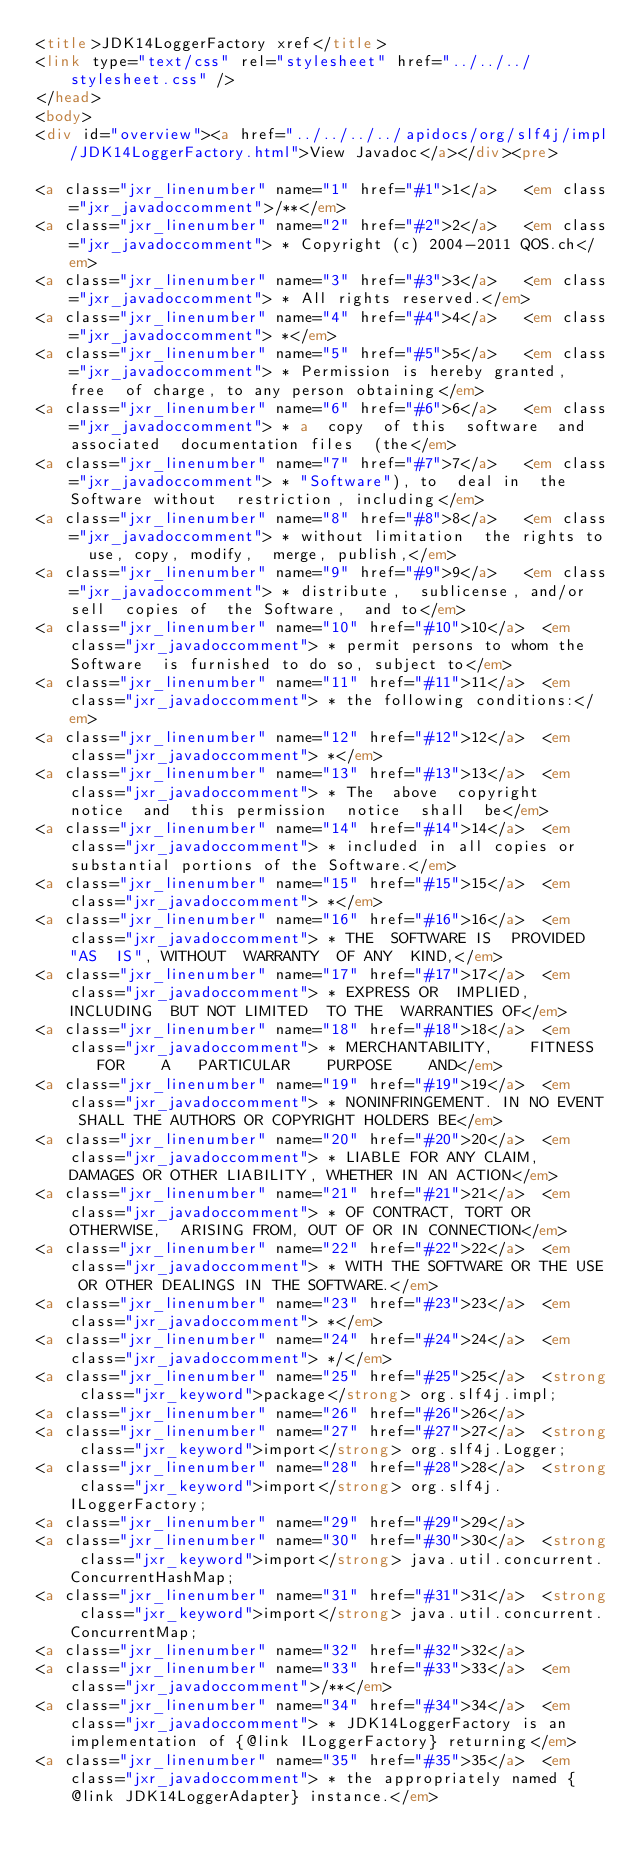Convert code to text. <code><loc_0><loc_0><loc_500><loc_500><_HTML_><title>JDK14LoggerFactory xref</title>
<link type="text/css" rel="stylesheet" href="../../../stylesheet.css" />
</head>
<body>
<div id="overview"><a href="../../../../apidocs/org/slf4j/impl/JDK14LoggerFactory.html">View Javadoc</a></div><pre>

<a class="jxr_linenumber" name="1" href="#1">1</a>   <em class="jxr_javadoccomment">/**</em>
<a class="jxr_linenumber" name="2" href="#2">2</a>   <em class="jxr_javadoccomment"> * Copyright (c) 2004-2011 QOS.ch</em>
<a class="jxr_linenumber" name="3" href="#3">3</a>   <em class="jxr_javadoccomment"> * All rights reserved.</em>
<a class="jxr_linenumber" name="4" href="#4">4</a>   <em class="jxr_javadoccomment"> *</em>
<a class="jxr_linenumber" name="5" href="#5">5</a>   <em class="jxr_javadoccomment"> * Permission is hereby granted, free  of charge, to any person obtaining</em>
<a class="jxr_linenumber" name="6" href="#6">6</a>   <em class="jxr_javadoccomment"> * a  copy  of this  software  and  associated  documentation files  (the</em>
<a class="jxr_linenumber" name="7" href="#7">7</a>   <em class="jxr_javadoccomment"> * "Software"), to  deal in  the Software without  restriction, including</em>
<a class="jxr_linenumber" name="8" href="#8">8</a>   <em class="jxr_javadoccomment"> * without limitation  the rights to  use, copy, modify,  merge, publish,</em>
<a class="jxr_linenumber" name="9" href="#9">9</a>   <em class="jxr_javadoccomment"> * distribute,  sublicense, and/or sell  copies of  the Software,  and to</em>
<a class="jxr_linenumber" name="10" href="#10">10</a>  <em class="jxr_javadoccomment"> * permit persons to whom the Software  is furnished to do so, subject to</em>
<a class="jxr_linenumber" name="11" href="#11">11</a>  <em class="jxr_javadoccomment"> * the following conditions:</em>
<a class="jxr_linenumber" name="12" href="#12">12</a>  <em class="jxr_javadoccomment"> *</em>
<a class="jxr_linenumber" name="13" href="#13">13</a>  <em class="jxr_javadoccomment"> * The  above  copyright  notice  and  this permission  notice  shall  be</em>
<a class="jxr_linenumber" name="14" href="#14">14</a>  <em class="jxr_javadoccomment"> * included in all copies or substantial portions of the Software.</em>
<a class="jxr_linenumber" name="15" href="#15">15</a>  <em class="jxr_javadoccomment"> *</em>
<a class="jxr_linenumber" name="16" href="#16">16</a>  <em class="jxr_javadoccomment"> * THE  SOFTWARE IS  PROVIDED  "AS  IS", WITHOUT  WARRANTY  OF ANY  KIND,</em>
<a class="jxr_linenumber" name="17" href="#17">17</a>  <em class="jxr_javadoccomment"> * EXPRESS OR  IMPLIED, INCLUDING  BUT NOT LIMITED  TO THE  WARRANTIES OF</em>
<a class="jxr_linenumber" name="18" href="#18">18</a>  <em class="jxr_javadoccomment"> * MERCHANTABILITY,    FITNESS    FOR    A   PARTICULAR    PURPOSE    AND</em>
<a class="jxr_linenumber" name="19" href="#19">19</a>  <em class="jxr_javadoccomment"> * NONINFRINGEMENT. IN NO EVENT SHALL THE AUTHORS OR COPYRIGHT HOLDERS BE</em>
<a class="jxr_linenumber" name="20" href="#20">20</a>  <em class="jxr_javadoccomment"> * LIABLE FOR ANY CLAIM, DAMAGES OR OTHER LIABILITY, WHETHER IN AN ACTION</em>
<a class="jxr_linenumber" name="21" href="#21">21</a>  <em class="jxr_javadoccomment"> * OF CONTRACT, TORT OR OTHERWISE,  ARISING FROM, OUT OF OR IN CONNECTION</em>
<a class="jxr_linenumber" name="22" href="#22">22</a>  <em class="jxr_javadoccomment"> * WITH THE SOFTWARE OR THE USE OR OTHER DEALINGS IN THE SOFTWARE.</em>
<a class="jxr_linenumber" name="23" href="#23">23</a>  <em class="jxr_javadoccomment"> *</em>
<a class="jxr_linenumber" name="24" href="#24">24</a>  <em class="jxr_javadoccomment"> */</em>
<a class="jxr_linenumber" name="25" href="#25">25</a>  <strong class="jxr_keyword">package</strong> org.slf4j.impl;
<a class="jxr_linenumber" name="26" href="#26">26</a>  
<a class="jxr_linenumber" name="27" href="#27">27</a>  <strong class="jxr_keyword">import</strong> org.slf4j.Logger;
<a class="jxr_linenumber" name="28" href="#28">28</a>  <strong class="jxr_keyword">import</strong> org.slf4j.ILoggerFactory;
<a class="jxr_linenumber" name="29" href="#29">29</a>  
<a class="jxr_linenumber" name="30" href="#30">30</a>  <strong class="jxr_keyword">import</strong> java.util.concurrent.ConcurrentHashMap;
<a class="jxr_linenumber" name="31" href="#31">31</a>  <strong class="jxr_keyword">import</strong> java.util.concurrent.ConcurrentMap;
<a class="jxr_linenumber" name="32" href="#32">32</a>  
<a class="jxr_linenumber" name="33" href="#33">33</a>  <em class="jxr_javadoccomment">/**</em>
<a class="jxr_linenumber" name="34" href="#34">34</a>  <em class="jxr_javadoccomment"> * JDK14LoggerFactory is an implementation of {@link ILoggerFactory} returning</em>
<a class="jxr_linenumber" name="35" href="#35">35</a>  <em class="jxr_javadoccomment"> * the appropriately named {@link JDK14LoggerAdapter} instance.</em></code> 